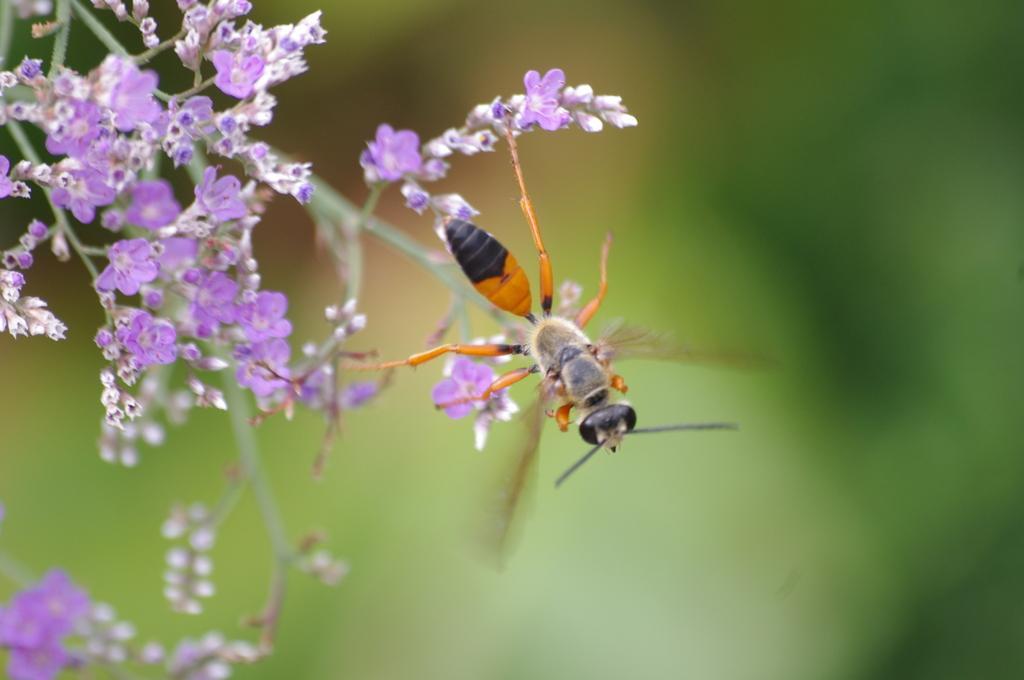In one or two sentences, can you explain what this image depicts? On the top left there are a bunch of flowers, on the there is an ant, in the background it is blurred. 